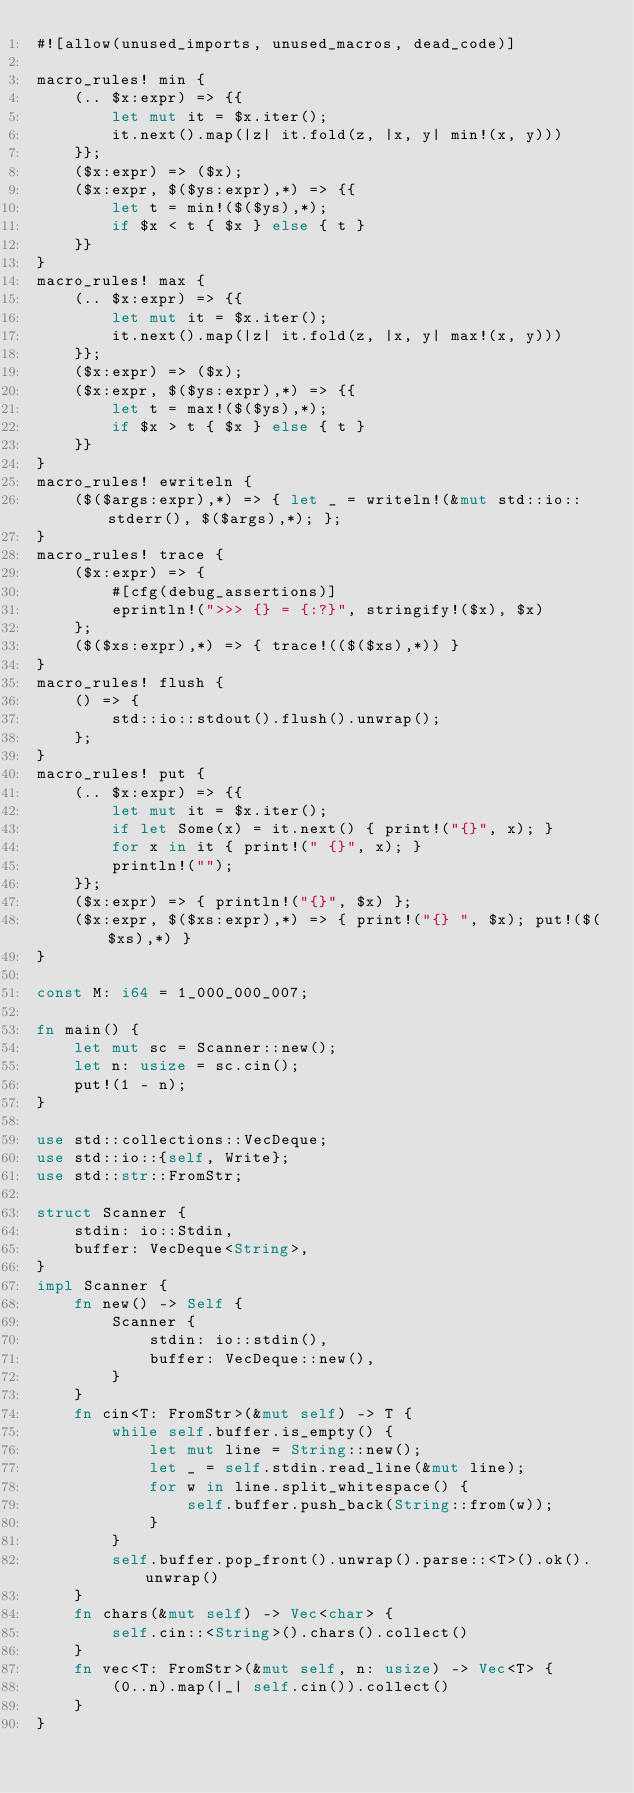Convert code to text. <code><loc_0><loc_0><loc_500><loc_500><_Rust_>#![allow(unused_imports, unused_macros, dead_code)]

macro_rules! min {
    (.. $x:expr) => {{
        let mut it = $x.iter();
        it.next().map(|z| it.fold(z, |x, y| min!(x, y)))
    }};
    ($x:expr) => ($x);
    ($x:expr, $($ys:expr),*) => {{
        let t = min!($($ys),*);
        if $x < t { $x } else { t }
    }}
}
macro_rules! max {
    (.. $x:expr) => {{
        let mut it = $x.iter();
        it.next().map(|z| it.fold(z, |x, y| max!(x, y)))
    }};
    ($x:expr) => ($x);
    ($x:expr, $($ys:expr),*) => {{
        let t = max!($($ys),*);
        if $x > t { $x } else { t }
    }}
}
macro_rules! ewriteln {
    ($($args:expr),*) => { let _ = writeln!(&mut std::io::stderr(), $($args),*); };
}
macro_rules! trace {
    ($x:expr) => {
        #[cfg(debug_assertions)]
        eprintln!(">>> {} = {:?}", stringify!($x), $x)
    };
    ($($xs:expr),*) => { trace!(($($xs),*)) }
}
macro_rules! flush {
    () => {
        std::io::stdout().flush().unwrap();
    };
}
macro_rules! put {
    (.. $x:expr) => {{
        let mut it = $x.iter();
        if let Some(x) = it.next() { print!("{}", x); }
        for x in it { print!(" {}", x); }
        println!("");
    }};
    ($x:expr) => { println!("{}", $x) };
    ($x:expr, $($xs:expr),*) => { print!("{} ", $x); put!($($xs),*) }
}

const M: i64 = 1_000_000_007;

fn main() {
    let mut sc = Scanner::new();
    let n: usize = sc.cin();
    put!(1 - n);
}

use std::collections::VecDeque;
use std::io::{self, Write};
use std::str::FromStr;

struct Scanner {
    stdin: io::Stdin,
    buffer: VecDeque<String>,
}
impl Scanner {
    fn new() -> Self {
        Scanner {
            stdin: io::stdin(),
            buffer: VecDeque::new(),
        }
    }
    fn cin<T: FromStr>(&mut self) -> T {
        while self.buffer.is_empty() {
            let mut line = String::new();
            let _ = self.stdin.read_line(&mut line);
            for w in line.split_whitespace() {
                self.buffer.push_back(String::from(w));
            }
        }
        self.buffer.pop_front().unwrap().parse::<T>().ok().unwrap()
    }
    fn chars(&mut self) -> Vec<char> {
        self.cin::<String>().chars().collect()
    }
    fn vec<T: FromStr>(&mut self, n: usize) -> Vec<T> {
        (0..n).map(|_| self.cin()).collect()
    }
}
</code> 